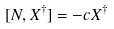Convert formula to latex. <formula><loc_0><loc_0><loc_500><loc_500>[ N , X ^ { \dagger } ] = - c X ^ { \dagger }</formula> 